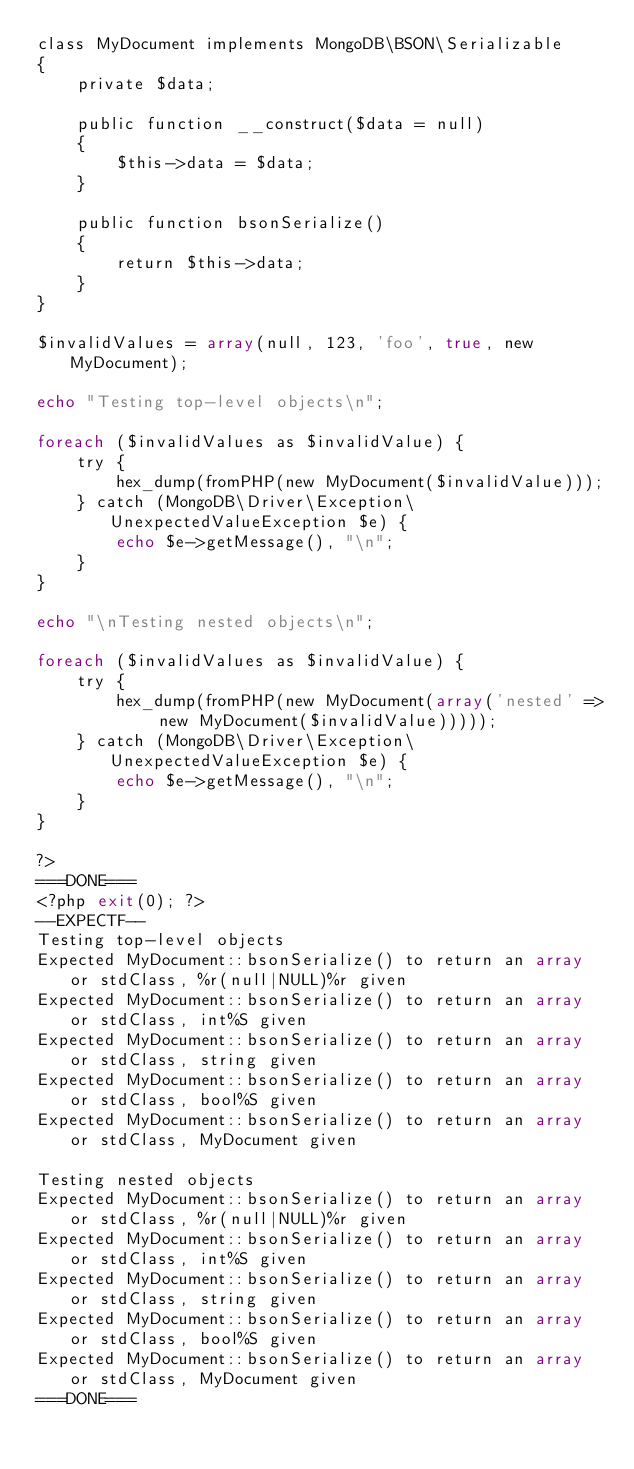<code> <loc_0><loc_0><loc_500><loc_500><_PHP_>class MyDocument implements MongoDB\BSON\Serializable
{
    private $data;

    public function __construct($data = null)
    {
        $this->data = $data;
    }

    public function bsonSerialize()
    {
        return $this->data;
    }
}

$invalidValues = array(null, 123, 'foo', true, new MyDocument);

echo "Testing top-level objects\n";

foreach ($invalidValues as $invalidValue) {
    try {
        hex_dump(fromPHP(new MyDocument($invalidValue)));
    } catch (MongoDB\Driver\Exception\UnexpectedValueException $e) {
        echo $e->getMessage(), "\n";
    }
}

echo "\nTesting nested objects\n";

foreach ($invalidValues as $invalidValue) {
    try {
        hex_dump(fromPHP(new MyDocument(array('nested' => new MyDocument($invalidValue)))));
    } catch (MongoDB\Driver\Exception\UnexpectedValueException $e) {
        echo $e->getMessage(), "\n";
    }
}

?>
===DONE===
<?php exit(0); ?>
--EXPECTF--
Testing top-level objects
Expected MyDocument::bsonSerialize() to return an array or stdClass, %r(null|NULL)%r given
Expected MyDocument::bsonSerialize() to return an array or stdClass, int%S given
Expected MyDocument::bsonSerialize() to return an array or stdClass, string given
Expected MyDocument::bsonSerialize() to return an array or stdClass, bool%S given
Expected MyDocument::bsonSerialize() to return an array or stdClass, MyDocument given

Testing nested objects
Expected MyDocument::bsonSerialize() to return an array or stdClass, %r(null|NULL)%r given
Expected MyDocument::bsonSerialize() to return an array or stdClass, int%S given
Expected MyDocument::bsonSerialize() to return an array or stdClass, string given
Expected MyDocument::bsonSerialize() to return an array or stdClass, bool%S given
Expected MyDocument::bsonSerialize() to return an array or stdClass, MyDocument given
===DONE===
</code> 